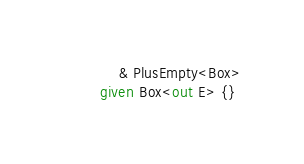<code> <loc_0><loc_0><loc_500><loc_500><_Ceylon_>            & PlusEmpty<Box>
        given Box<out E> {}</code> 